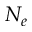Convert formula to latex. <formula><loc_0><loc_0><loc_500><loc_500>N _ { e }</formula> 